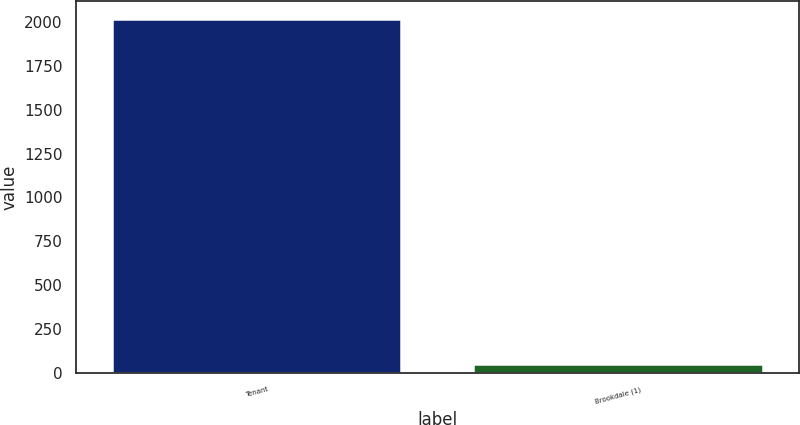Convert chart to OTSL. <chart><loc_0><loc_0><loc_500><loc_500><bar_chart><fcel>Tenant<fcel>Brookdale (1)<nl><fcel>2015<fcel>53<nl></chart> 